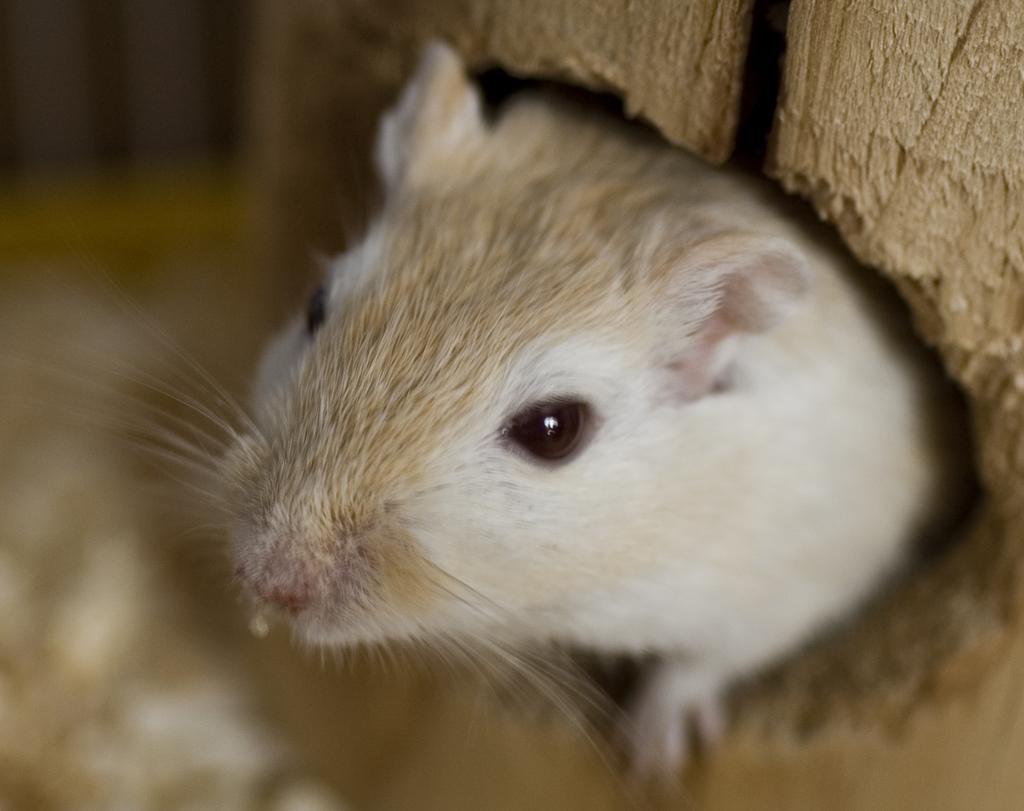Describe this image in one or two sentences. In this image I can see a rat which is in white and brown color. Background the image is blurred. 